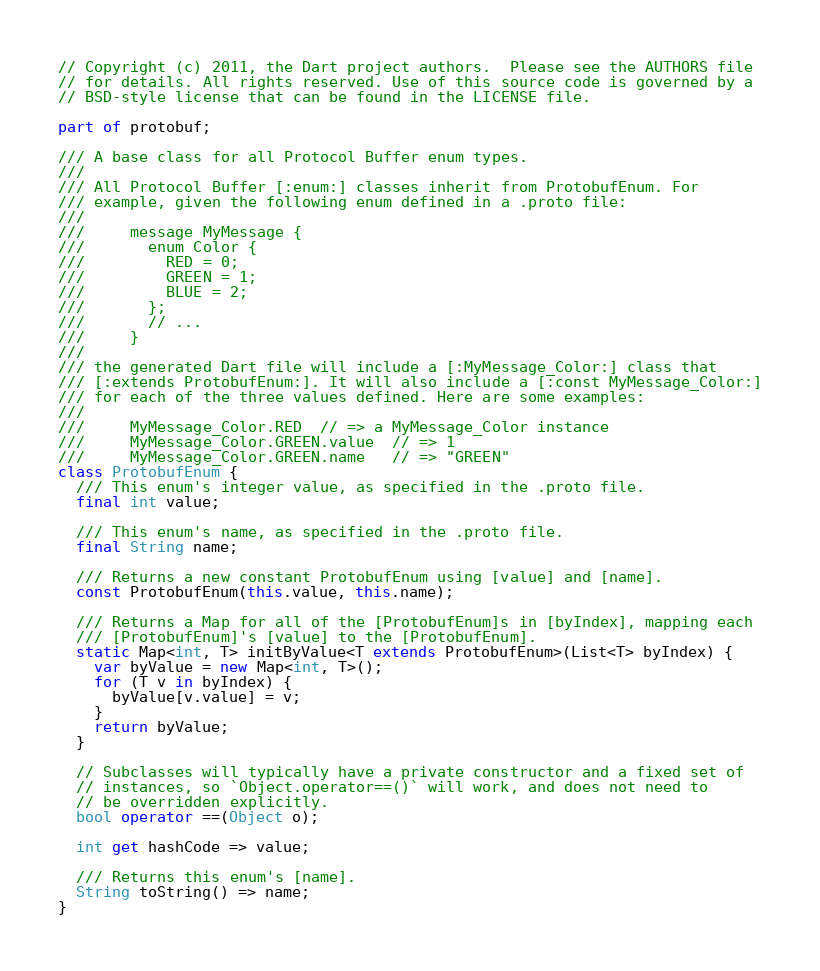<code> <loc_0><loc_0><loc_500><loc_500><_Dart_>// Copyright (c) 2011, the Dart project authors.  Please see the AUTHORS file
// for details. All rights reserved. Use of this source code is governed by a
// BSD-style license that can be found in the LICENSE file.

part of protobuf;

/// A base class for all Protocol Buffer enum types.
///
/// All Protocol Buffer [:enum:] classes inherit from ProtobufEnum. For
/// example, given the following enum defined in a .proto file:
///
///     message MyMessage {
///       enum Color {
///         RED = 0;
///         GREEN = 1;
///         BLUE = 2;
///       };
///       // ...
///     }
///
/// the generated Dart file will include a [:MyMessage_Color:] class that
/// [:extends ProtobufEnum:]. It will also include a [:const MyMessage_Color:]
/// for each of the three values defined. Here are some examples:
///
///     MyMessage_Color.RED  // => a MyMessage_Color instance
///     MyMessage_Color.GREEN.value  // => 1
///     MyMessage_Color.GREEN.name   // => "GREEN"
class ProtobufEnum {
  /// This enum's integer value, as specified in the .proto file.
  final int value;

  /// This enum's name, as specified in the .proto file.
  final String name;

  /// Returns a new constant ProtobufEnum using [value] and [name].
  const ProtobufEnum(this.value, this.name);

  /// Returns a Map for all of the [ProtobufEnum]s in [byIndex], mapping each
  /// [ProtobufEnum]'s [value] to the [ProtobufEnum].
  static Map<int, T> initByValue<T extends ProtobufEnum>(List<T> byIndex) {
    var byValue = new Map<int, T>();
    for (T v in byIndex) {
      byValue[v.value] = v;
    }
    return byValue;
  }

  // Subclasses will typically have a private constructor and a fixed set of
  // instances, so `Object.operator==()` will work, and does not need to
  // be overridden explicitly.
  bool operator ==(Object o);

  int get hashCode => value;

  /// Returns this enum's [name].
  String toString() => name;
}
</code> 